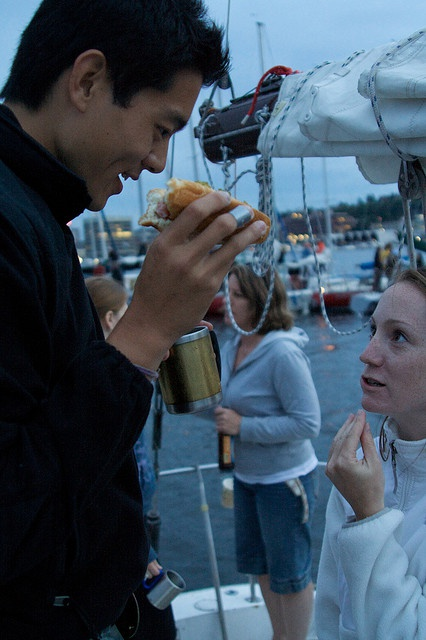Describe the objects in this image and their specific colors. I can see people in lightblue, black, and gray tones, people in lightblue and gray tones, people in lightblue, black, blue, and gray tones, boat in lightblue, gray, and black tones, and boat in lightblue, gray, and blue tones in this image. 